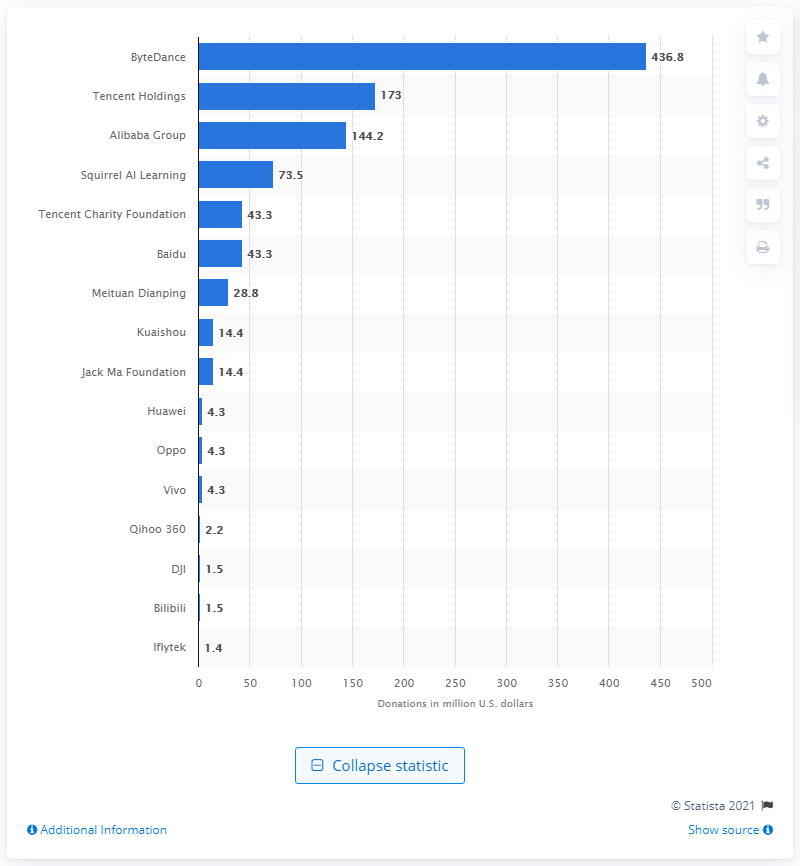Highlight a few significant elements in this photo. ByteDance has donated a total of 436.8 million US dollars to combat the COVID-19 pandemic. 